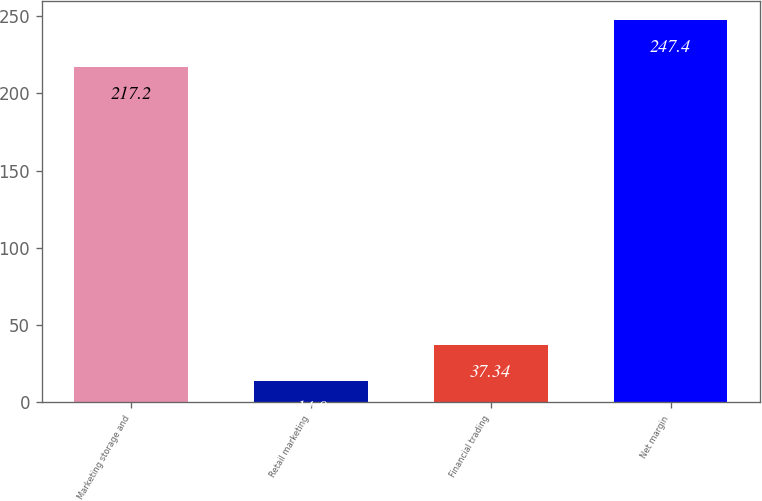<chart> <loc_0><loc_0><loc_500><loc_500><bar_chart><fcel>Marketing storage and<fcel>Retail marketing<fcel>Financial trading<fcel>Net margin<nl><fcel>217.2<fcel>14<fcel>37.34<fcel>247.4<nl></chart> 